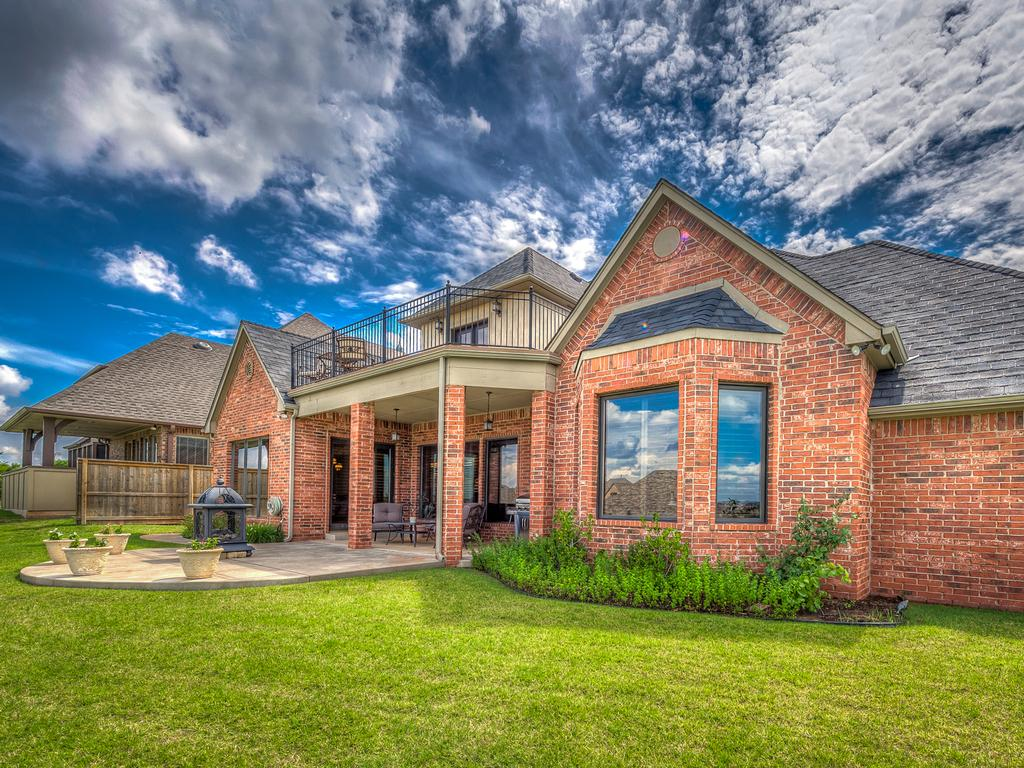What type of vegetation can be seen in the image? There is grass and plants in the image. What type of structures are present in the image? There are houses in the image. What can be seen in the background of the image? There are clouds visible in the background of the image. What type of cakes are being prepared by the carpenter during the holiday in the image? There is no carpenter, holiday, or cakes present in the image. 